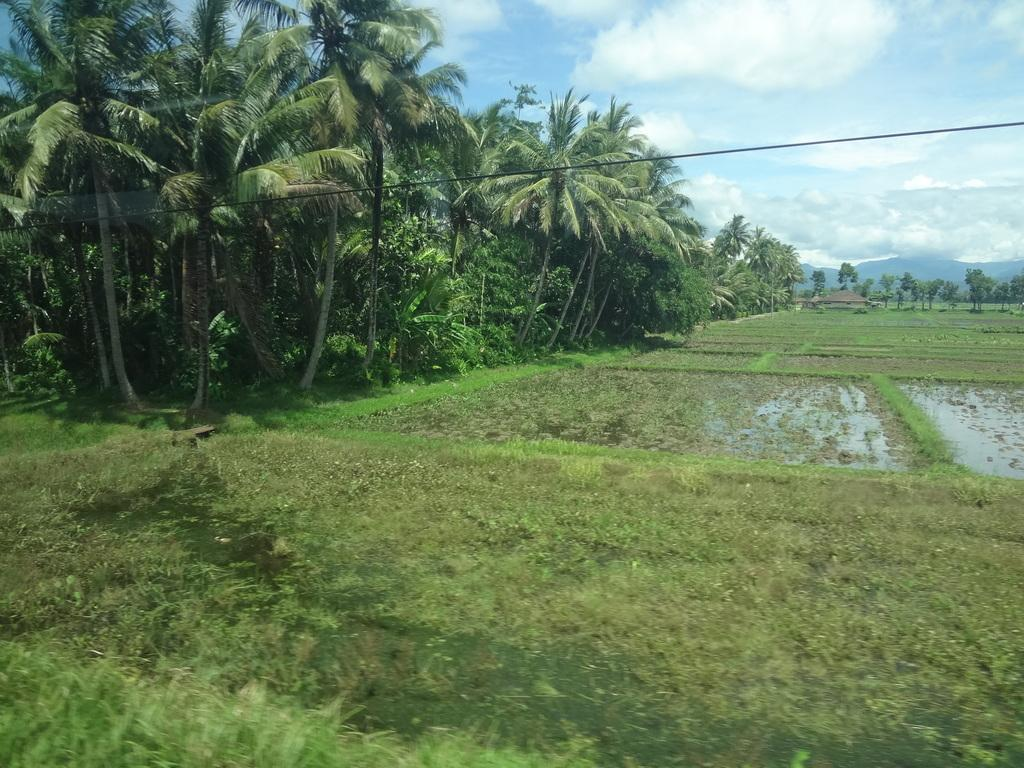What type of vegetation is present in the image? There is grass in the image. What else can be seen in the image besides grass? There is water and trees visible in the image. What is visible in the background of the image? The sky and a wire are visible in the background of the image. What type of fiction is being read by the company in the image? There is no company or fiction present in the image; it features grass, water, trees, the sky, and a wire. Can you hear the thunder in the image? There is no thunder present in the image; it is a still image with no sound. 